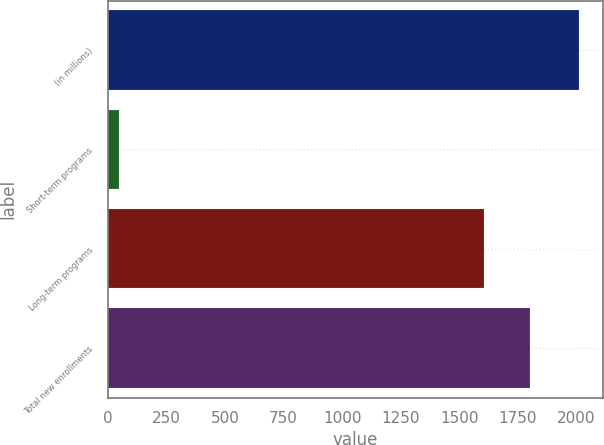<chart> <loc_0><loc_0><loc_500><loc_500><bar_chart><fcel>(in millions)<fcel>Short-term programs<fcel>Long-term programs<fcel>Total new enrollments<nl><fcel>2012<fcel>47<fcel>1607<fcel>1803.5<nl></chart> 